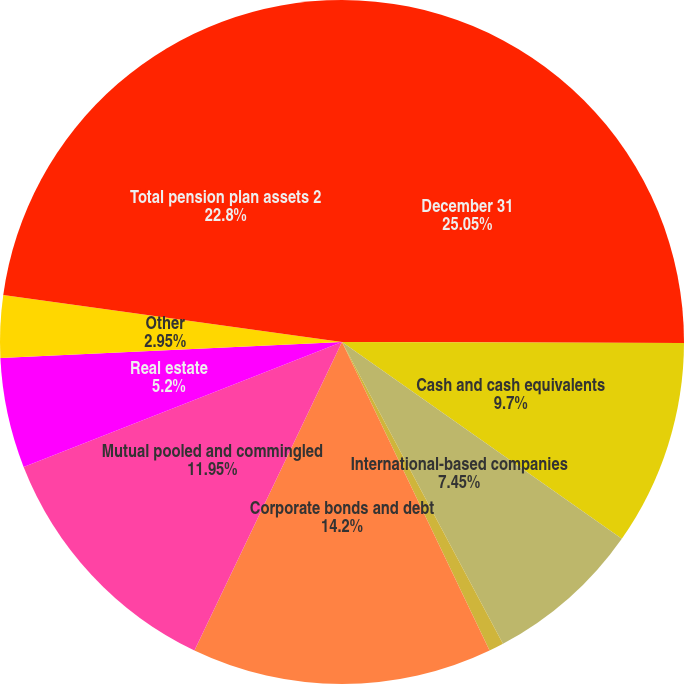Convert chart to OTSL. <chart><loc_0><loc_0><loc_500><loc_500><pie_chart><fcel>December 31<fcel>Cash and cash equivalents<fcel>International-based companies<fcel>Government bonds<fcel>Corporate bonds and debt<fcel>Mutual pooled and commingled<fcel>Real estate<fcel>Other<fcel>Total pension plan assets 2<nl><fcel>25.05%<fcel>9.7%<fcel>7.45%<fcel>0.7%<fcel>14.2%<fcel>11.95%<fcel>5.2%<fcel>2.95%<fcel>22.8%<nl></chart> 